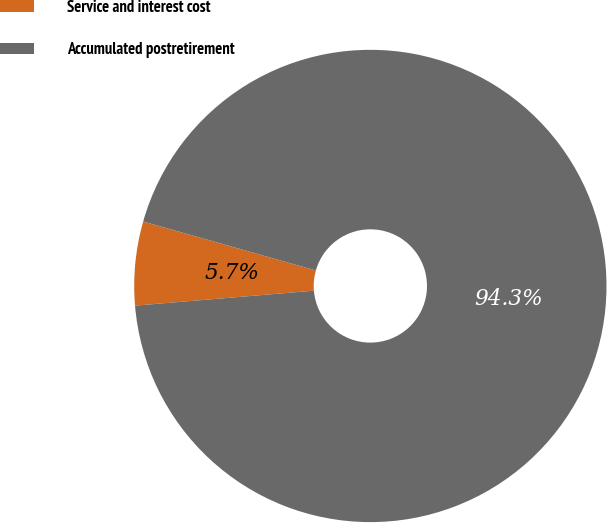<chart> <loc_0><loc_0><loc_500><loc_500><pie_chart><fcel>Service and interest cost<fcel>Accumulated postretirement<nl><fcel>5.73%<fcel>94.27%<nl></chart> 